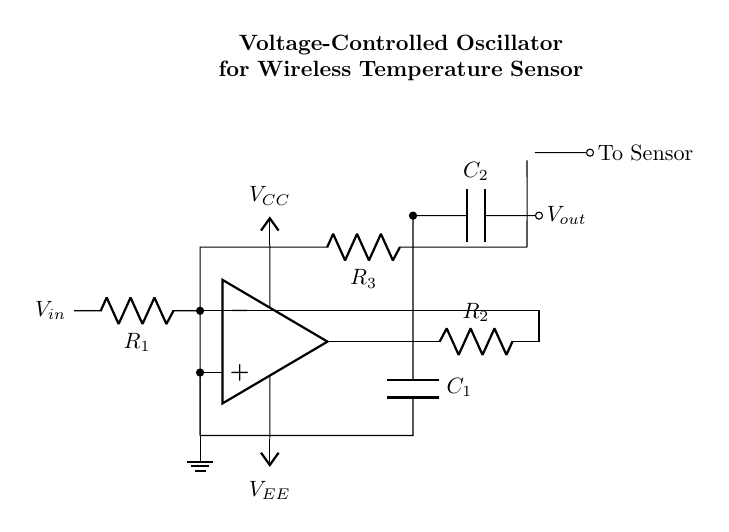What type of oscillator is this circuit? This circuit is a voltage-controlled oscillator, as indicated by the term "VCO" in the title. It generates oscillations where the frequency is controlled by an input voltage.
Answer: Voltage-controlled oscillator What is the purpose of the thermistor in the circuit? The thermistor serves as a temperature sensor to provide temperature readings to the oscillator circuit, influencing its frequency output based on temperature changes.
Answer: Temperature sensor What is the value of the capacitor connected to the output? The value of the capacitor connected to the output is labeled as C2 in the diagram, and it is responsible for coupling the output signal.
Answer: C2 How does the voltage supply affect the circuit? The circuit uses two voltage supplies: VCC for positive voltage and VEE for negative voltage, allowing the op-amp to function properly and drive the oscillator based on input conditions.
Answer: Power supply Which component provides feedback to the oscillator? The feedback to the oscillator is provided through the resistor R2, which connects the output back to the inverting input of the op-amp, forming a feedback loop essential for oscillation.
Answer: Resistor R2 What is the role of capacitor C1 in the circuit? Capacitor C1 is involved in the timing characteristics of the oscillator, influencing the frequency of oscillation along with resistors R1 and R2.
Answer: Timing component 